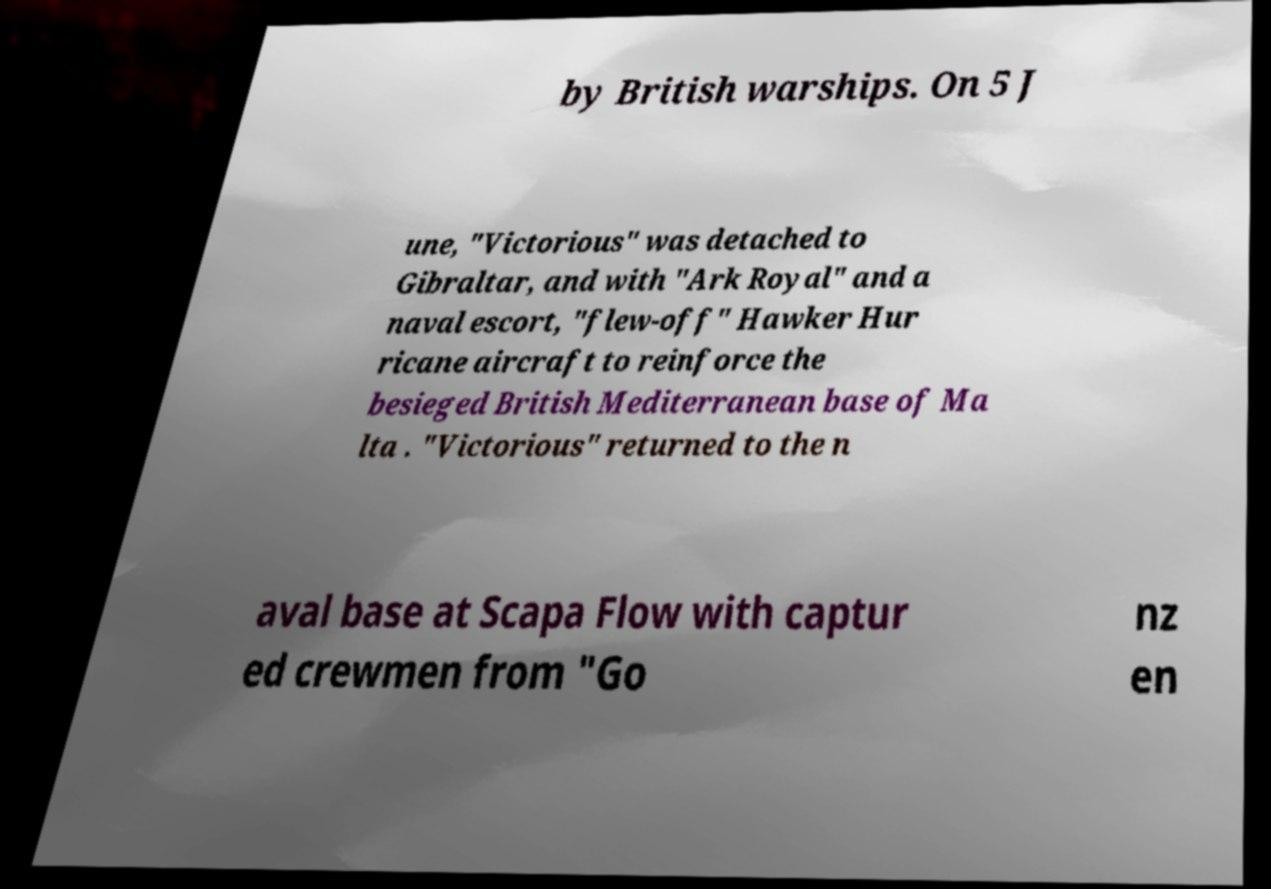There's text embedded in this image that I need extracted. Can you transcribe it verbatim? by British warships. On 5 J une, "Victorious" was detached to Gibraltar, and with "Ark Royal" and a naval escort, "flew-off" Hawker Hur ricane aircraft to reinforce the besieged British Mediterranean base of Ma lta . "Victorious" returned to the n aval base at Scapa Flow with captur ed crewmen from "Go nz en 